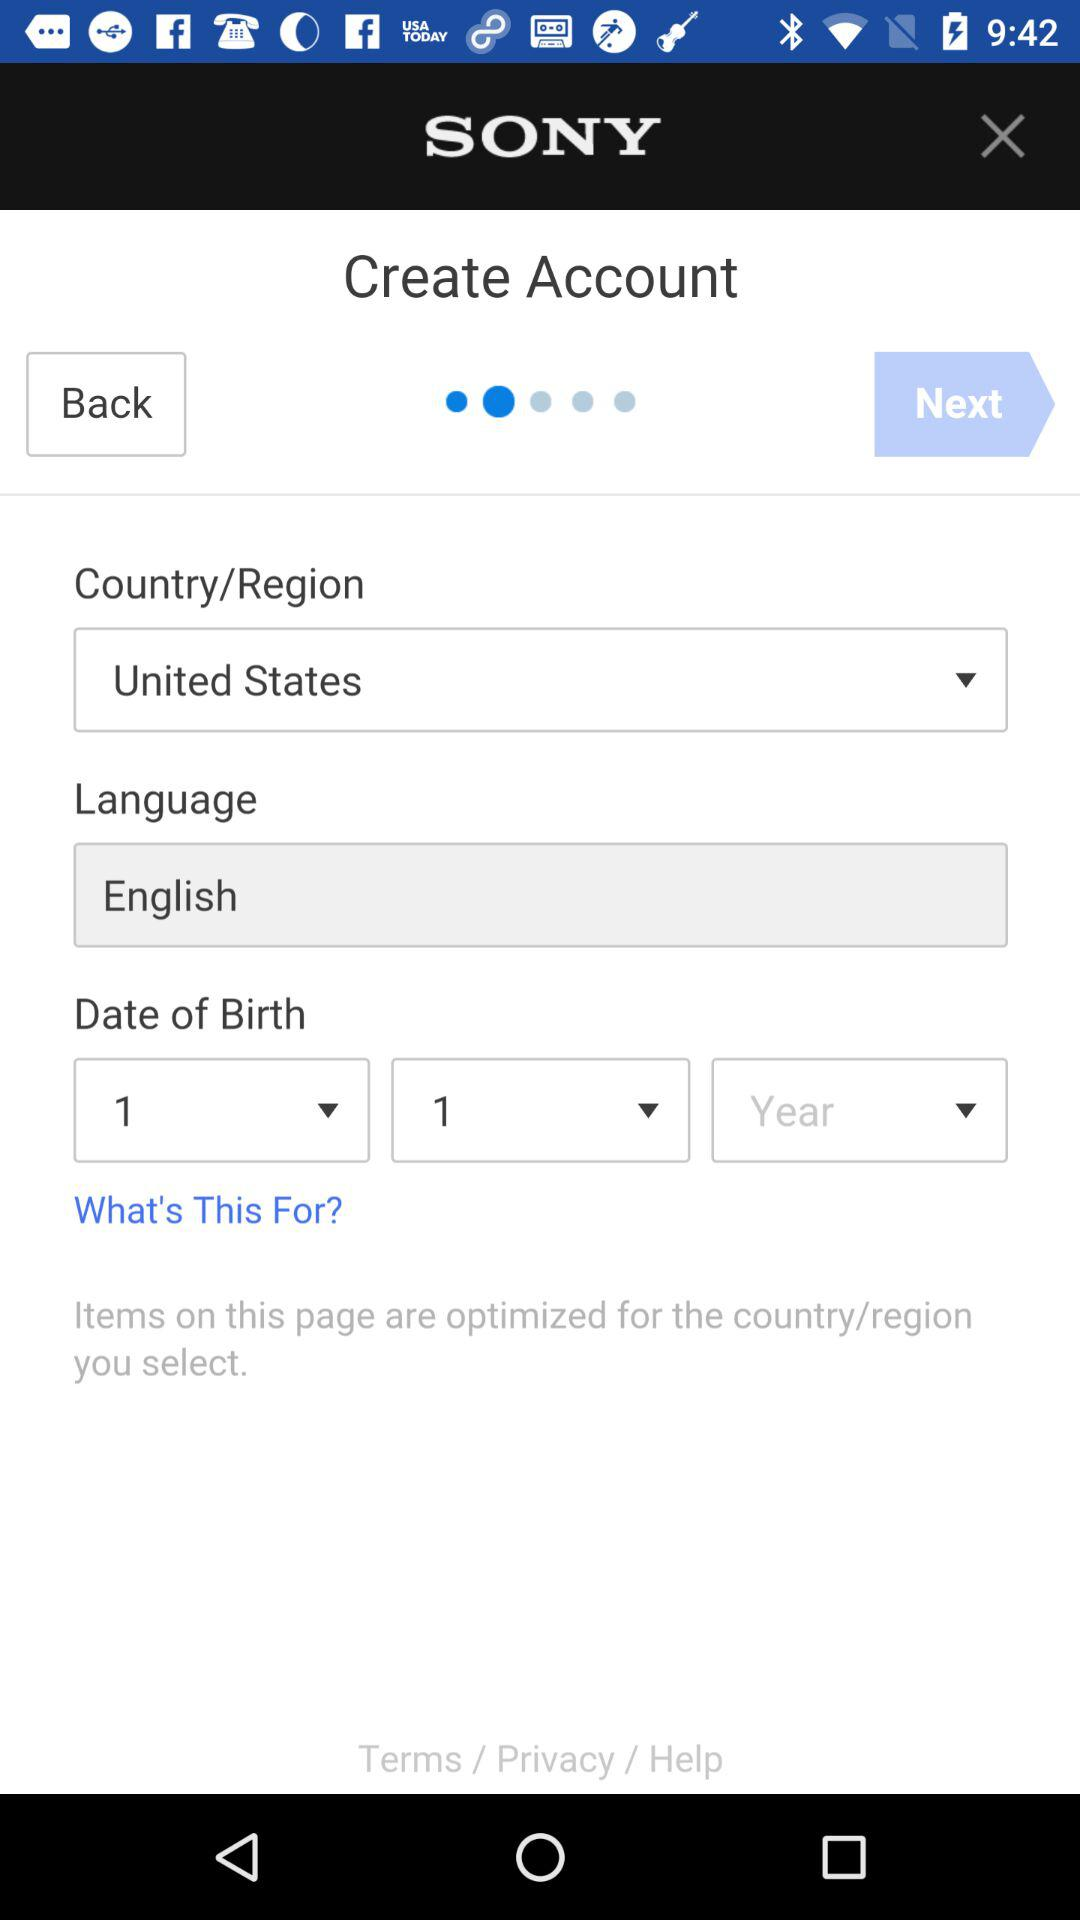What is the date of birth?
When the provided information is insufficient, respond with <no answer>. <no answer> 